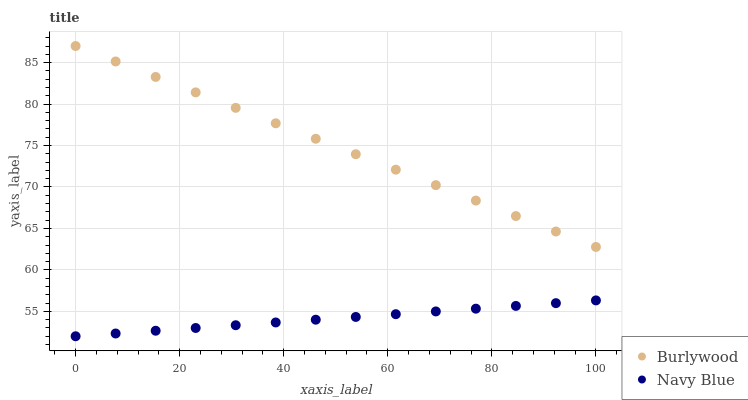Does Navy Blue have the minimum area under the curve?
Answer yes or no. Yes. Does Burlywood have the maximum area under the curve?
Answer yes or no. Yes. Does Navy Blue have the maximum area under the curve?
Answer yes or no. No. Is Burlywood the smoothest?
Answer yes or no. Yes. Is Navy Blue the roughest?
Answer yes or no. Yes. Is Navy Blue the smoothest?
Answer yes or no. No. Does Navy Blue have the lowest value?
Answer yes or no. Yes. Does Burlywood have the highest value?
Answer yes or no. Yes. Does Navy Blue have the highest value?
Answer yes or no. No. Is Navy Blue less than Burlywood?
Answer yes or no. Yes. Is Burlywood greater than Navy Blue?
Answer yes or no. Yes. Does Navy Blue intersect Burlywood?
Answer yes or no. No. 